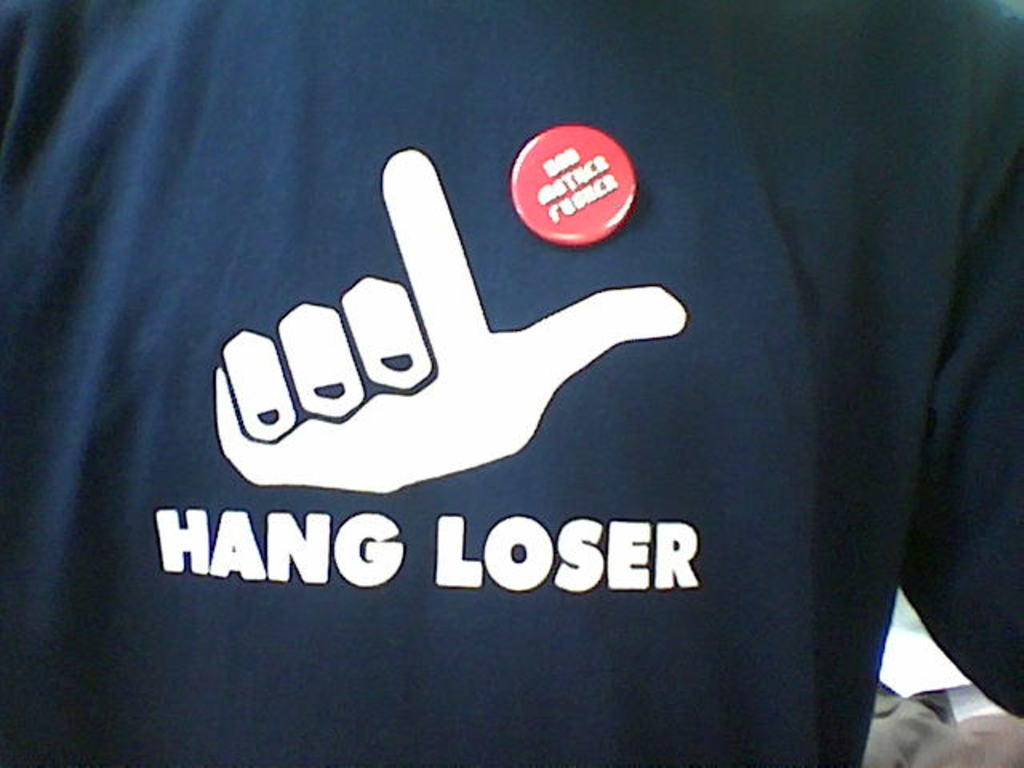Can you tell me more about the cultural context of the 'I'm with stupid' button? The 'I'm with stupid' button is part of a humorous trend in novelty items and clothing that peaked in popularity in the late 20th century. Such items are typically used in a lighthearted manner to poke fun at companions in social settings. The phrase implies that the wearer is jokingly calling someone nearby stupid, often pointing to the button as a punchline in jest. Is this style of humor well received everywhere? This style of humor, while popular and taken in good stride among friends in many cultures, can be seen as offensive or inappropriate in others. It's very context-dependent. In environments or cultures where direct or self-deprecating humor is appreciated, such items might be seen humorously. However, in settings that value respect and formality, or among individuals who aren't familiar with this humorous approach, it could be poorly received. 